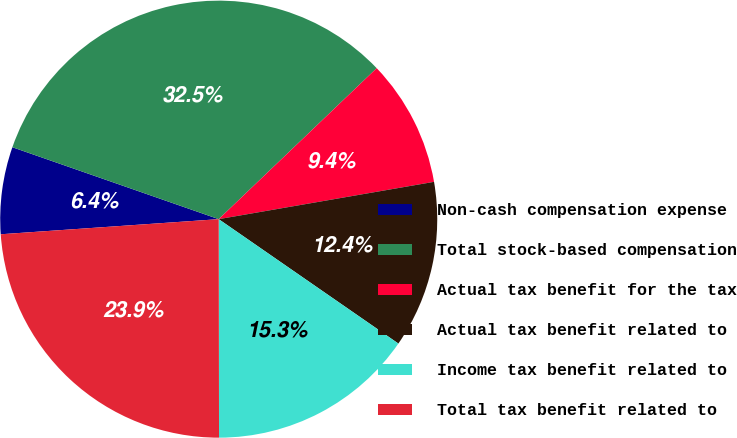<chart> <loc_0><loc_0><loc_500><loc_500><pie_chart><fcel>Non-cash compensation expense<fcel>Total stock-based compensation<fcel>Actual tax benefit for the tax<fcel>Actual tax benefit related to<fcel>Income tax benefit related to<fcel>Total tax benefit related to<nl><fcel>6.44%<fcel>32.52%<fcel>9.41%<fcel>12.37%<fcel>15.34%<fcel>23.92%<nl></chart> 